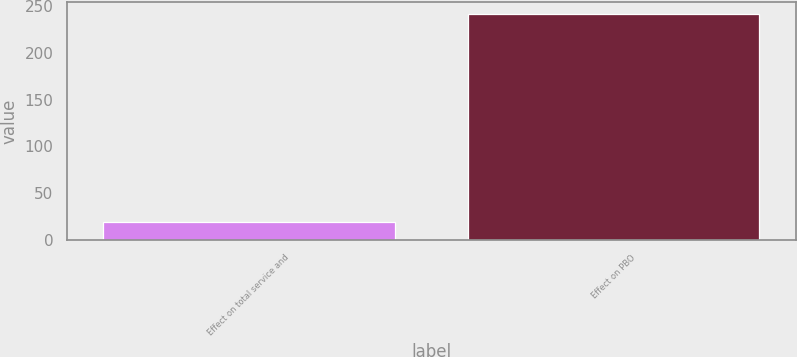Convert chart. <chart><loc_0><loc_0><loc_500><loc_500><bar_chart><fcel>Effect on total service and<fcel>Effect on PBO<nl><fcel>19<fcel>242<nl></chart> 